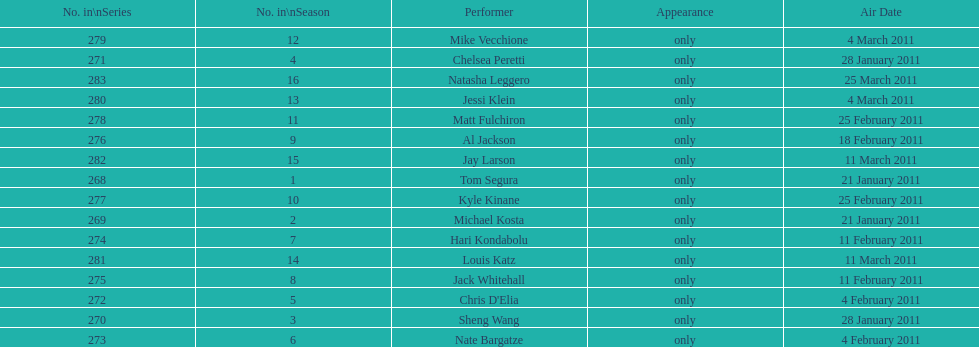How many episodes only had one performer? 16. 